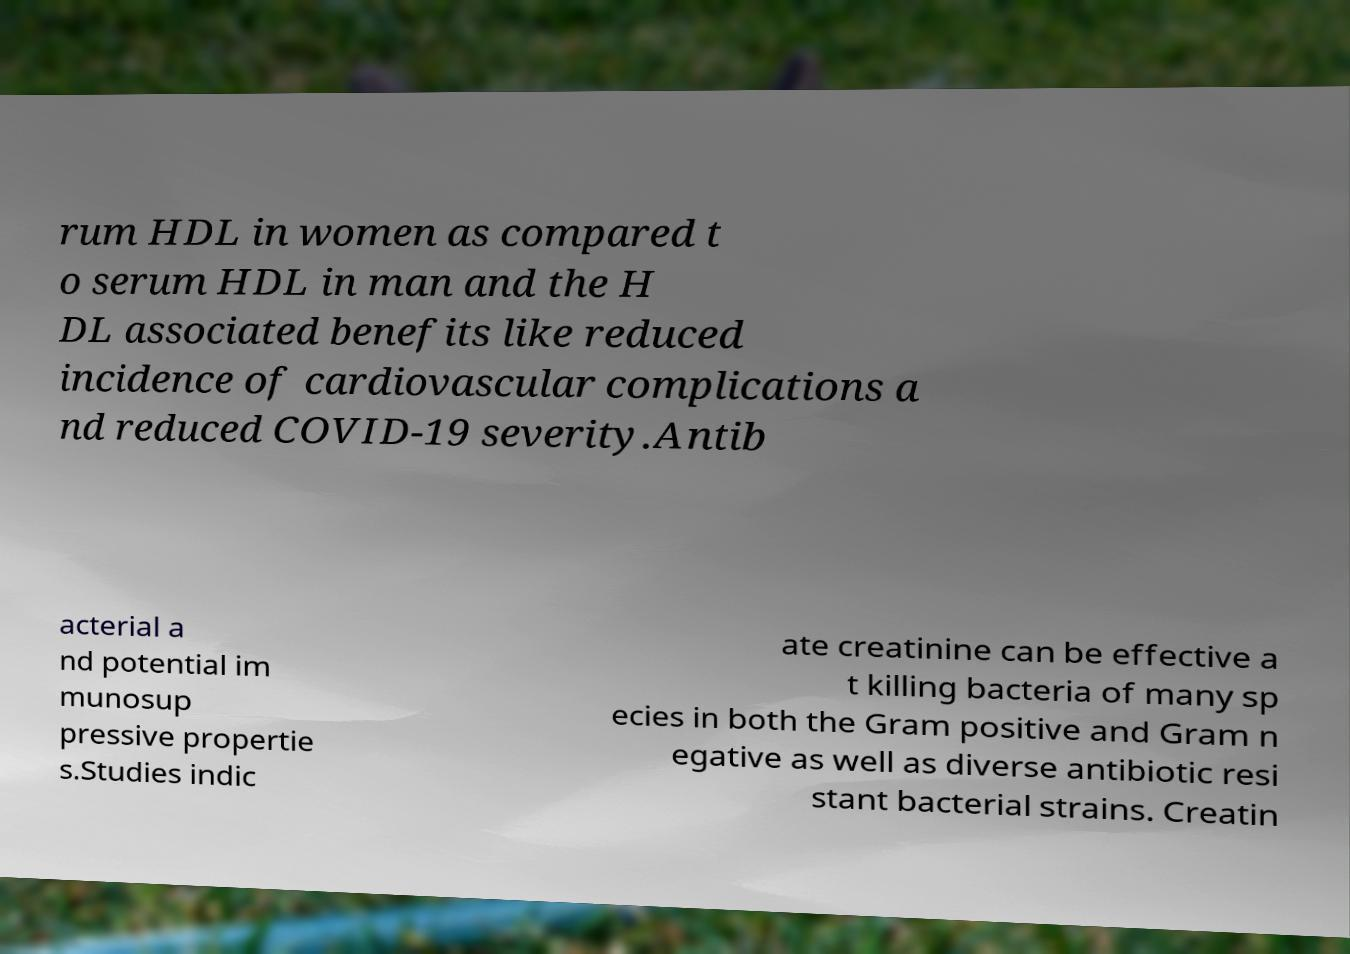What messages or text are displayed in this image? I need them in a readable, typed format. rum HDL in women as compared t o serum HDL in man and the H DL associated benefits like reduced incidence of cardiovascular complications a nd reduced COVID-19 severity.Antib acterial a nd potential im munosup pressive propertie s.Studies indic ate creatinine can be effective a t killing bacteria of many sp ecies in both the Gram positive and Gram n egative as well as diverse antibiotic resi stant bacterial strains. Creatin 